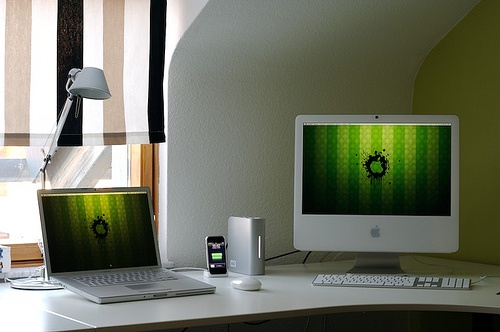Describe the objects in this image and their specific colors. I can see tv in white, black, gray, and darkgreen tones, laptop in white, black, gray, and darkgreen tones, keyboard in white, gray, darkgray, and black tones, cell phone in white, black, gray, darkgray, and lightgray tones, and mouse in white, darkgray, lightgray, and gray tones in this image. 